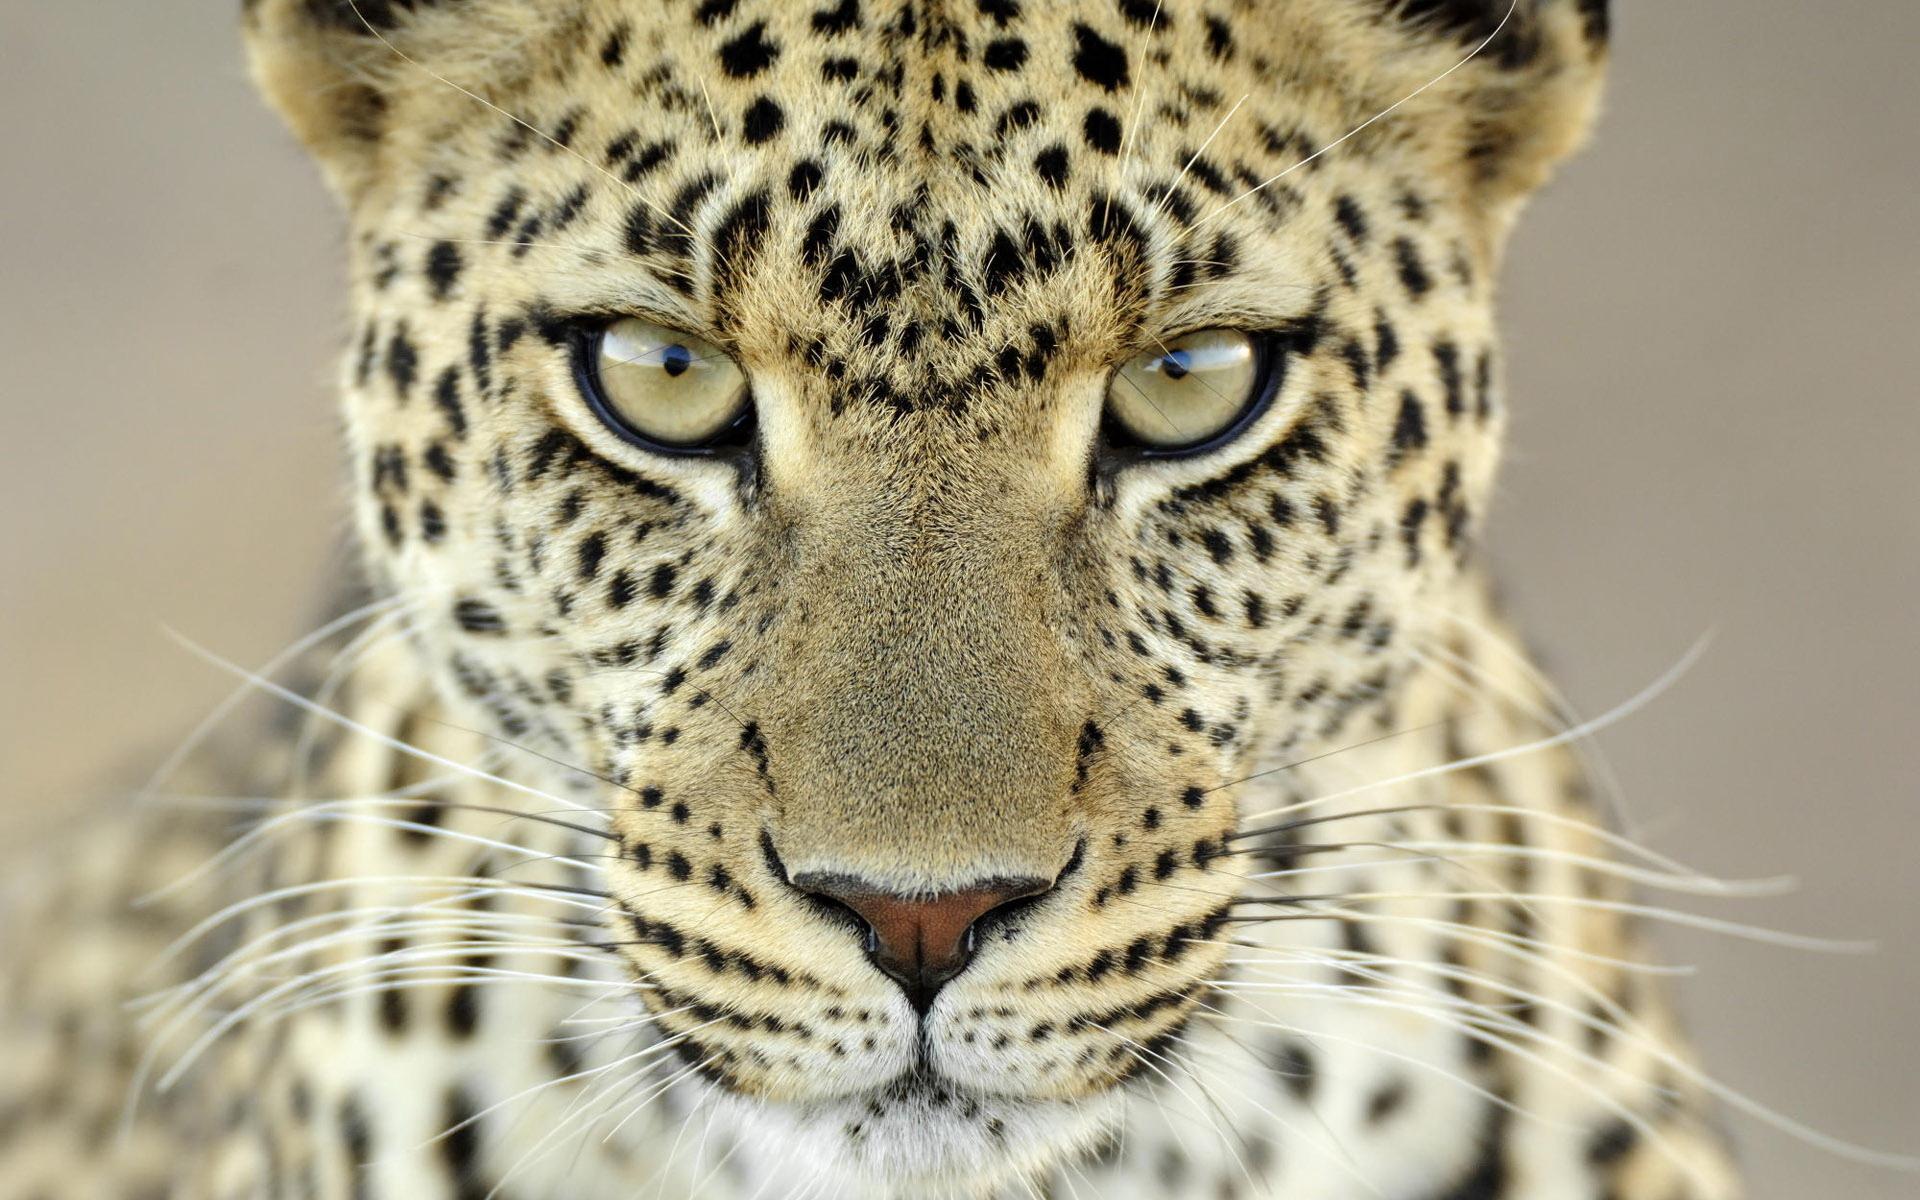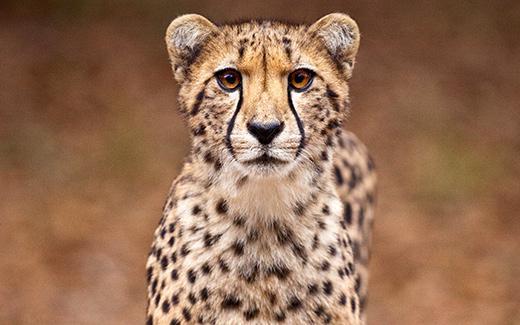The first image is the image on the left, the second image is the image on the right. Given the left and right images, does the statement "There is at least 1 leopard kitten." hold true? Answer yes or no. No. 